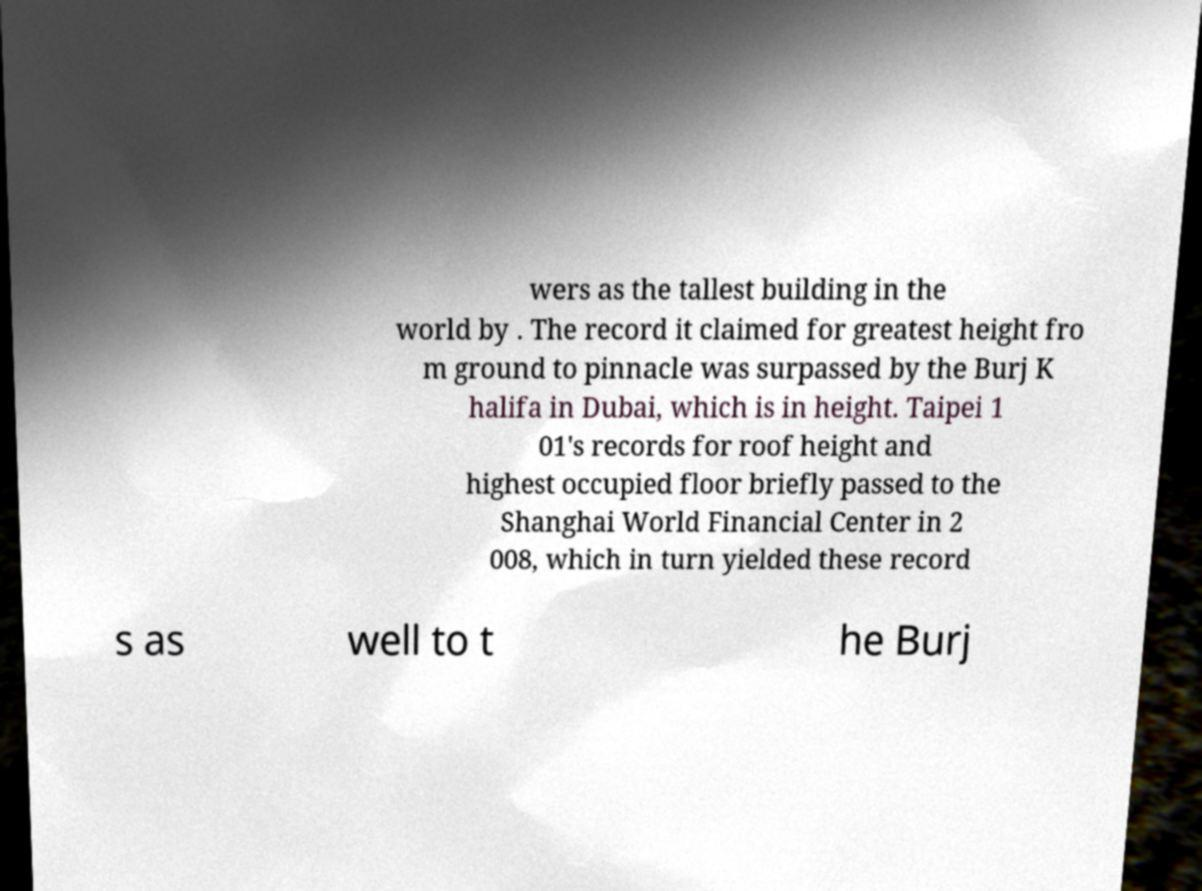For documentation purposes, I need the text within this image transcribed. Could you provide that? wers as the tallest building in the world by . The record it claimed for greatest height fro m ground to pinnacle was surpassed by the Burj K halifa in Dubai, which is in height. Taipei 1 01's records for roof height and highest occupied floor briefly passed to the Shanghai World Financial Center in 2 008, which in turn yielded these record s as well to t he Burj 